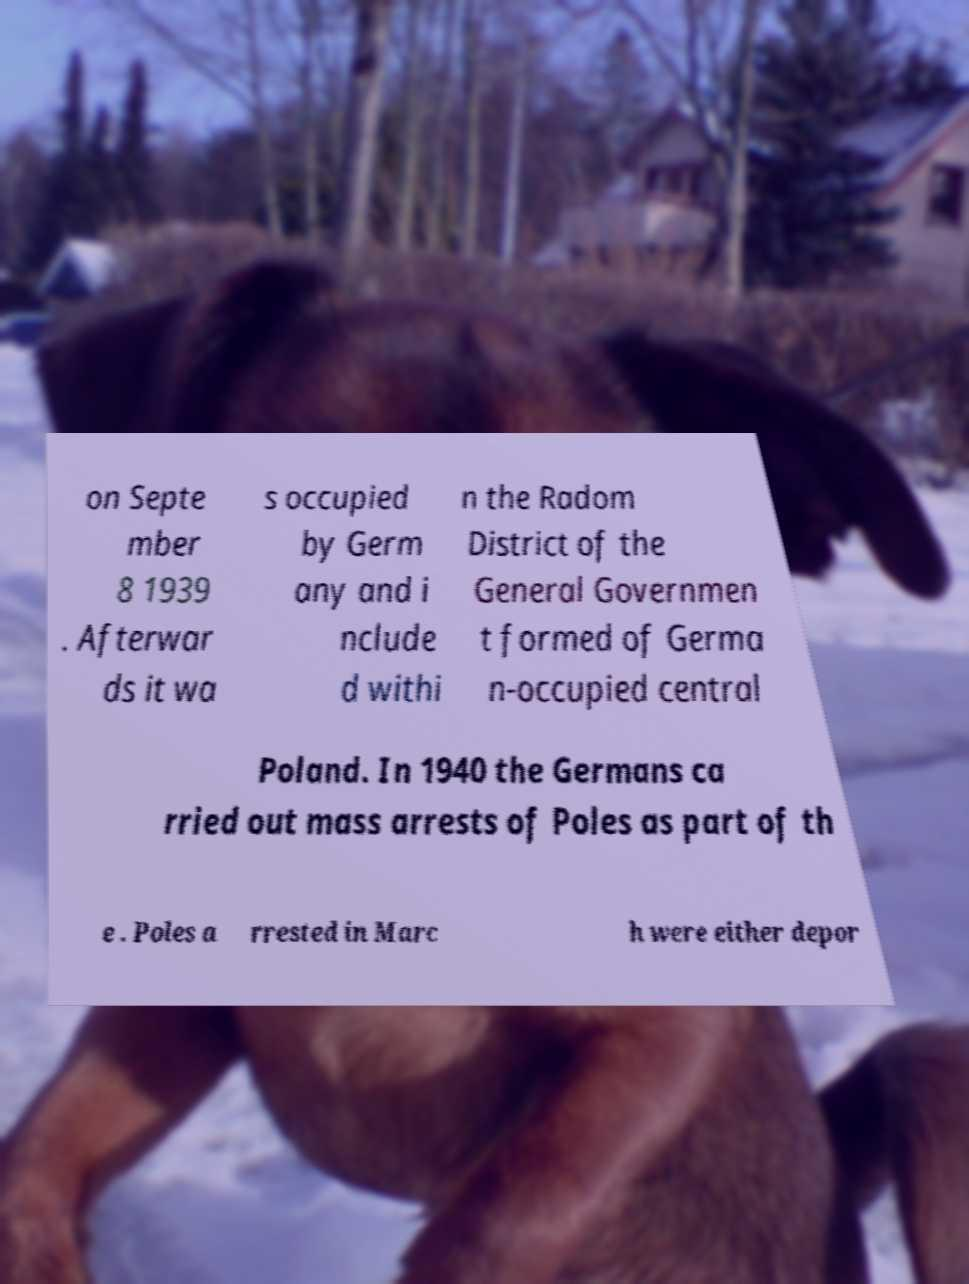What messages or text are displayed in this image? I need them in a readable, typed format. on Septe mber 8 1939 . Afterwar ds it wa s occupied by Germ any and i nclude d withi n the Radom District of the General Governmen t formed of Germa n-occupied central Poland. In 1940 the Germans ca rried out mass arrests of Poles as part of th e . Poles a rrested in Marc h were either depor 